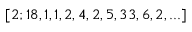<formula> <loc_0><loc_0><loc_500><loc_500>[ 2 ; 1 8 , 1 , 1 , 2 , 4 , 2 , 5 , 3 3 , 6 , 2 , \dots ]</formula> 